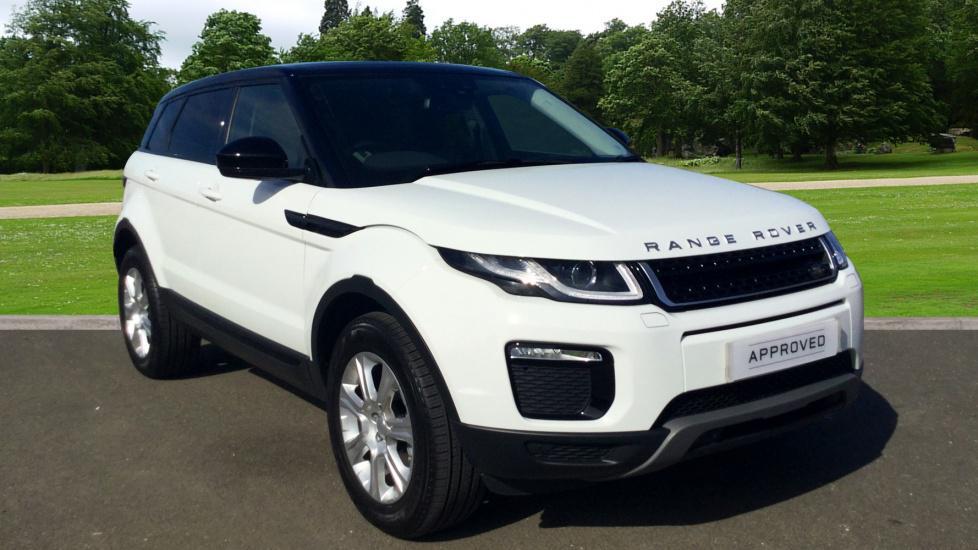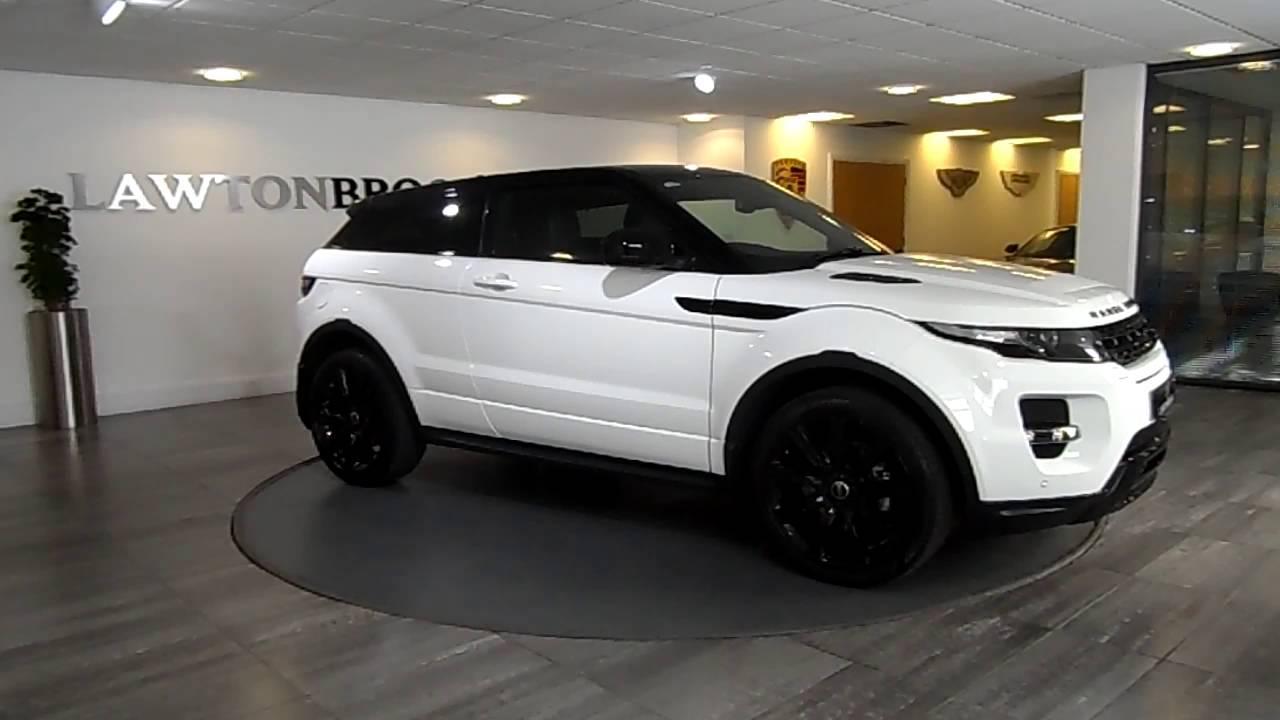The first image is the image on the left, the second image is the image on the right. Given the left and right images, does the statement "Each image shows a white Range Rover with its top covered, but one car has black rims while the other has silver rims." hold true? Answer yes or no. Yes. The first image is the image on the left, the second image is the image on the right. For the images displayed, is the sentence "The right image contains a white vehicle that is facing towards the right." factually correct? Answer yes or no. Yes. 